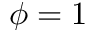Convert formula to latex. <formula><loc_0><loc_0><loc_500><loc_500>\phi = 1</formula> 